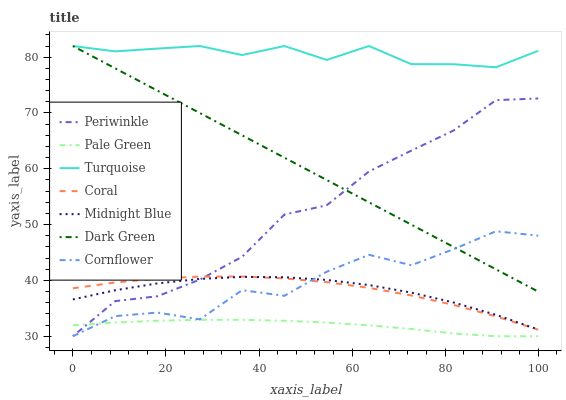Does Midnight Blue have the minimum area under the curve?
Answer yes or no. No. Does Midnight Blue have the maximum area under the curve?
Answer yes or no. No. Is Turquoise the smoothest?
Answer yes or no. No. Is Turquoise the roughest?
Answer yes or no. No. Does Midnight Blue have the lowest value?
Answer yes or no. No. Does Midnight Blue have the highest value?
Answer yes or no. No. Is Coral less than Turquoise?
Answer yes or no. Yes. Is Dark Green greater than Pale Green?
Answer yes or no. Yes. Does Coral intersect Turquoise?
Answer yes or no. No. 